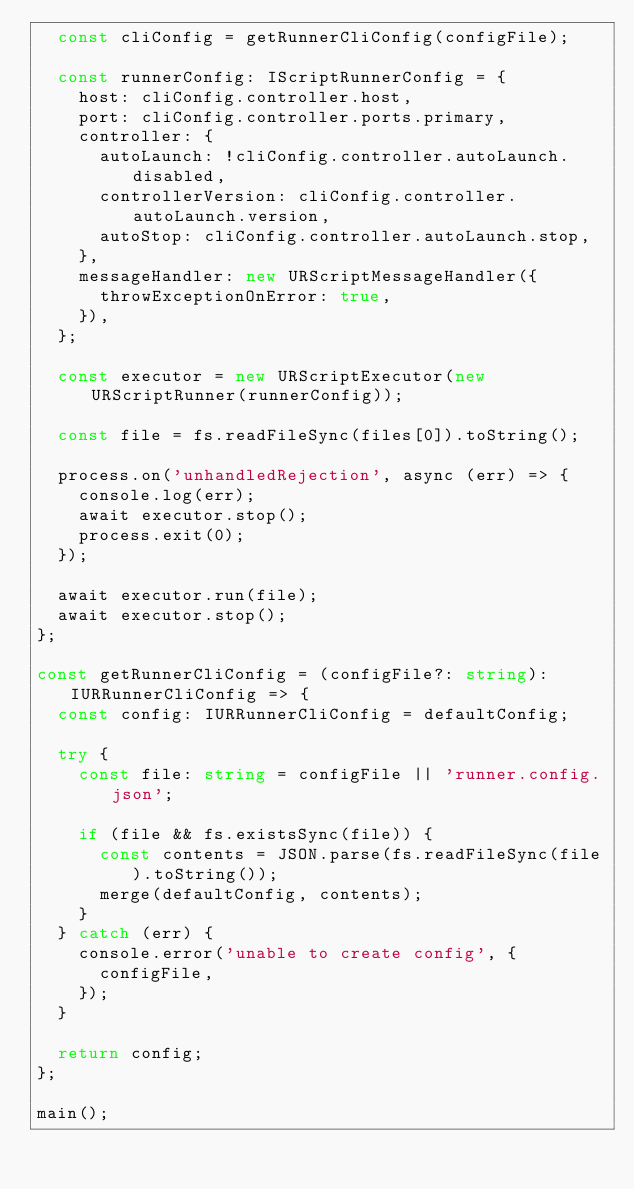Convert code to text. <code><loc_0><loc_0><loc_500><loc_500><_TypeScript_>  const cliConfig = getRunnerCliConfig(configFile);

  const runnerConfig: IScriptRunnerConfig = {
    host: cliConfig.controller.host,
    port: cliConfig.controller.ports.primary,
    controller: {
      autoLaunch: !cliConfig.controller.autoLaunch.disabled,
      controllerVersion: cliConfig.controller.autoLaunch.version,
      autoStop: cliConfig.controller.autoLaunch.stop,
    },
    messageHandler: new URScriptMessageHandler({
      throwExceptionOnError: true,
    }),
  };

  const executor = new URScriptExecutor(new URScriptRunner(runnerConfig));

  const file = fs.readFileSync(files[0]).toString();

  process.on('unhandledRejection', async (err) => {
    console.log(err);
    await executor.stop();
    process.exit(0);
  });

  await executor.run(file);
  await executor.stop();
};

const getRunnerCliConfig = (configFile?: string): IURRunnerCliConfig => {
  const config: IURRunnerCliConfig = defaultConfig;

  try {
    const file: string = configFile || 'runner.config.json';

    if (file && fs.existsSync(file)) {
      const contents = JSON.parse(fs.readFileSync(file).toString());
      merge(defaultConfig, contents);
    }
  } catch (err) {
    console.error('unable to create config', {
      configFile,
    });
  }

  return config;
};

main();
</code> 